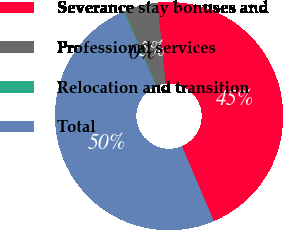<chart> <loc_0><loc_0><loc_500><loc_500><pie_chart><fcel>Severance stay bonuses and<fcel>Professional services<fcel>Relocation and transition<fcel>Total<nl><fcel>45.22%<fcel>4.78%<fcel>0.13%<fcel>49.87%<nl></chart> 